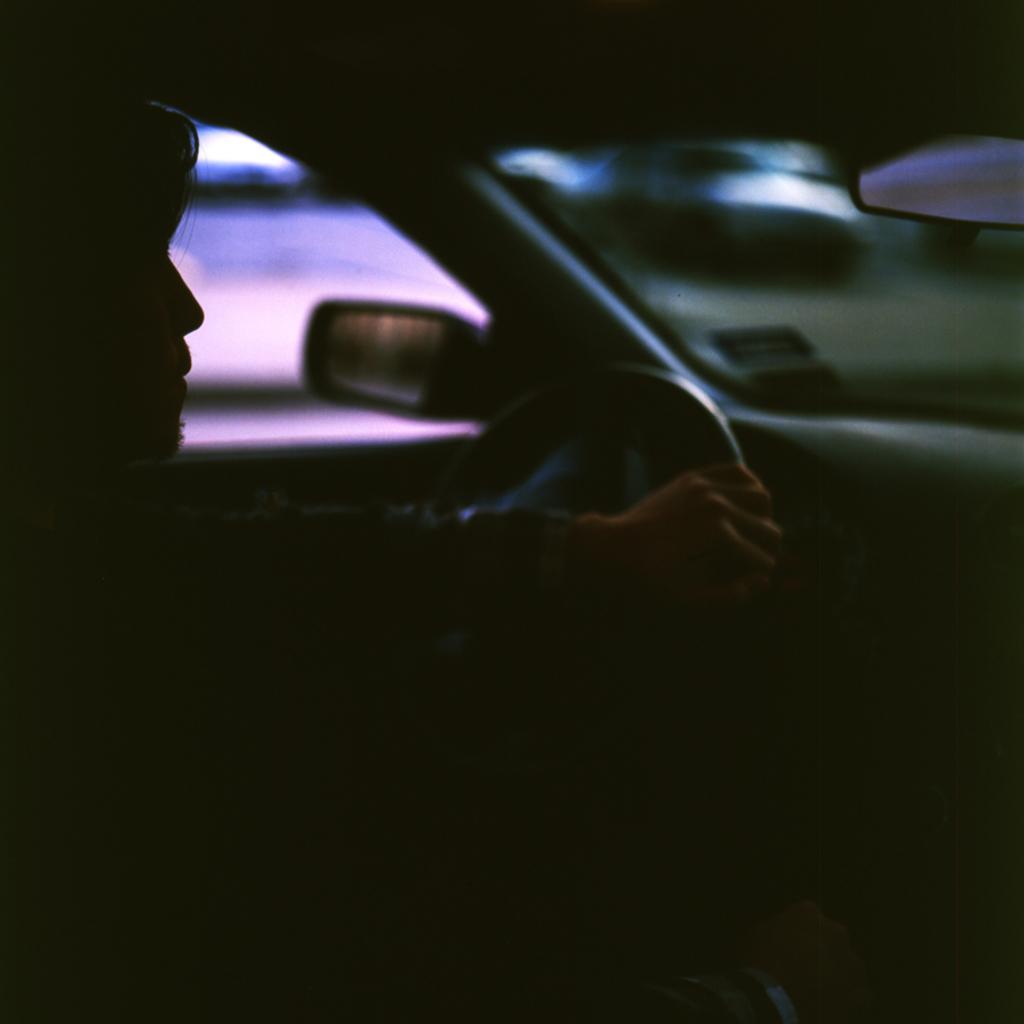How would you summarize this image in a sentence or two? In this image in the center there is a man driving a car holding a steering and there is a side mirror visible and there is a rear mirror and the background is blurry. 